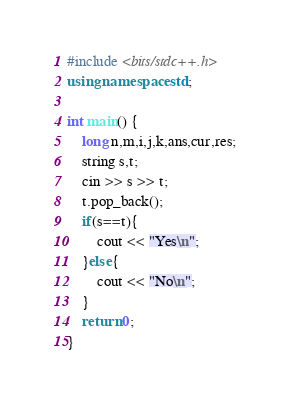<code> <loc_0><loc_0><loc_500><loc_500><_C++_>#include <bits/stdc++.h>
using namespace std;

int main() {
	long n,m,i,j,k,ans,cur,res;
	string s,t;
	cin >> s >> t;
	t.pop_back();
	if(s==t){
		cout << "Yes\n";
	}else{
		cout << "No\n";
	}
	return 0;
}</code> 